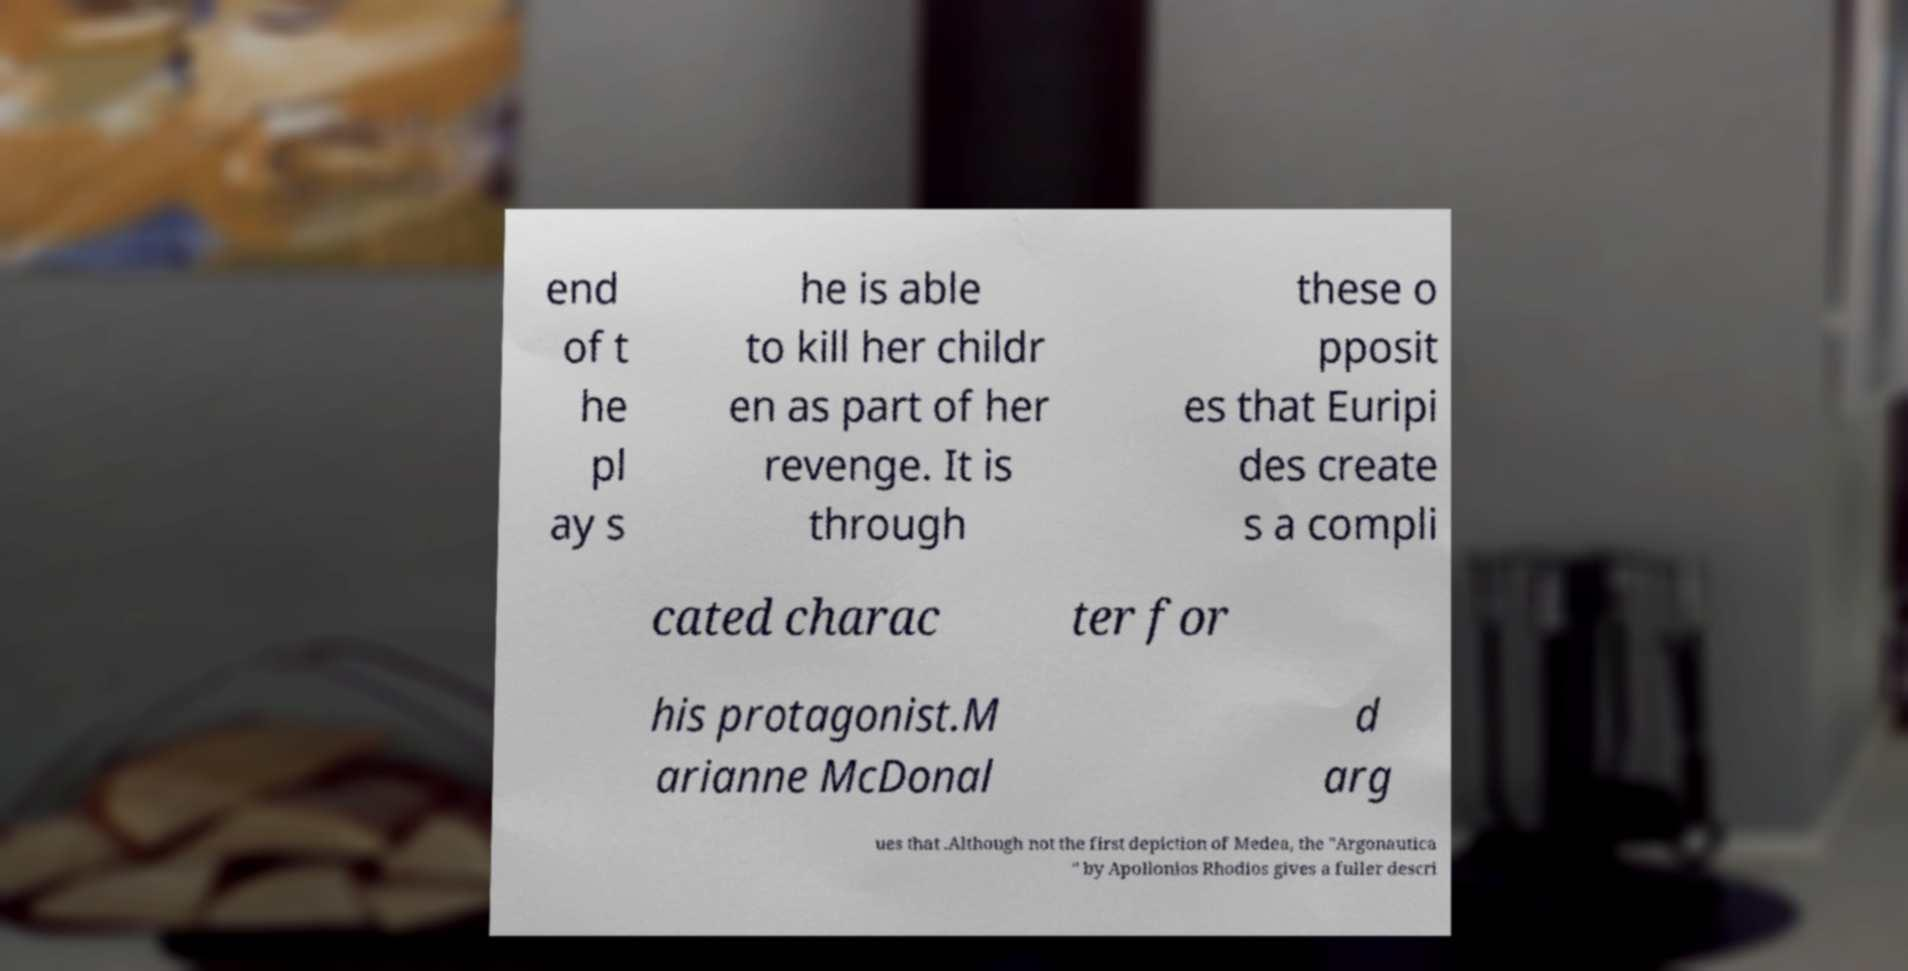Please identify and transcribe the text found in this image. end of t he pl ay s he is able to kill her childr en as part of her revenge. It is through these o pposit es that Euripi des create s a compli cated charac ter for his protagonist.M arianne McDonal d arg ues that .Although not the first depiction of Medea, the "Argonautica " by Apollonios Rhodios gives a fuller descri 